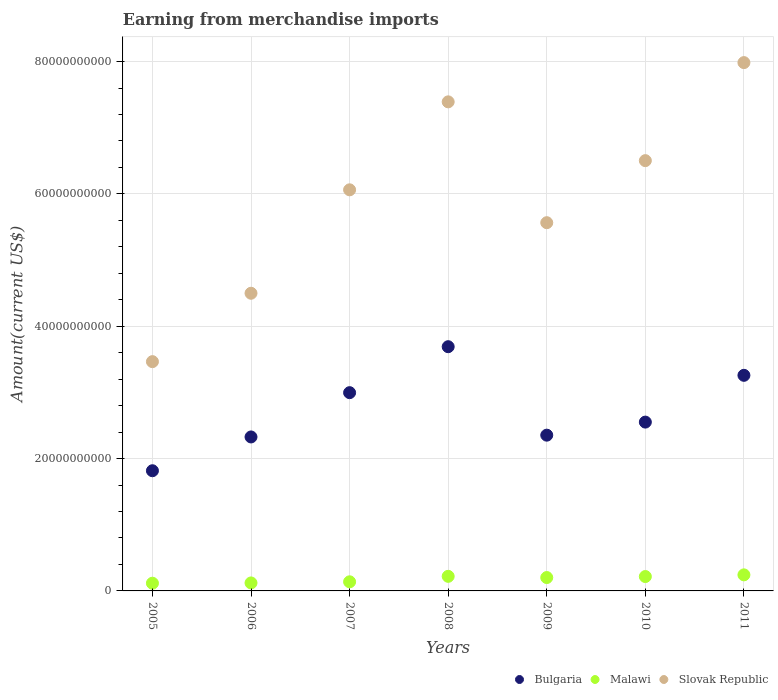Is the number of dotlines equal to the number of legend labels?
Give a very brief answer. Yes. What is the amount earned from merchandise imports in Slovak Republic in 2008?
Offer a very short reply. 7.39e+1. Across all years, what is the maximum amount earned from merchandise imports in Malawi?
Provide a succinct answer. 2.43e+09. Across all years, what is the minimum amount earned from merchandise imports in Malawi?
Offer a very short reply. 1.17e+09. In which year was the amount earned from merchandise imports in Malawi maximum?
Your response must be concise. 2011. What is the total amount earned from merchandise imports in Bulgaria in the graph?
Your answer should be very brief. 1.90e+11. What is the difference between the amount earned from merchandise imports in Bulgaria in 2008 and that in 2011?
Your answer should be very brief. 4.33e+09. What is the difference between the amount earned from merchandise imports in Slovak Republic in 2011 and the amount earned from merchandise imports in Malawi in 2005?
Give a very brief answer. 7.87e+1. What is the average amount earned from merchandise imports in Bulgaria per year?
Offer a very short reply. 2.71e+1. In the year 2010, what is the difference between the amount earned from merchandise imports in Bulgaria and amount earned from merchandise imports in Slovak Republic?
Your answer should be very brief. -3.95e+1. What is the ratio of the amount earned from merchandise imports in Slovak Republic in 2010 to that in 2011?
Keep it short and to the point. 0.81. Is the difference between the amount earned from merchandise imports in Bulgaria in 2006 and 2007 greater than the difference between the amount earned from merchandise imports in Slovak Republic in 2006 and 2007?
Make the answer very short. Yes. What is the difference between the highest and the second highest amount earned from merchandise imports in Bulgaria?
Offer a very short reply. 4.33e+09. What is the difference between the highest and the lowest amount earned from merchandise imports in Slovak Republic?
Offer a very short reply. 4.52e+1. In how many years, is the amount earned from merchandise imports in Slovak Republic greater than the average amount earned from merchandise imports in Slovak Republic taken over all years?
Offer a terse response. 4. How many years are there in the graph?
Make the answer very short. 7. What is the difference between two consecutive major ticks on the Y-axis?
Provide a short and direct response. 2.00e+1. Does the graph contain any zero values?
Ensure brevity in your answer.  No. Where does the legend appear in the graph?
Make the answer very short. Bottom right. How are the legend labels stacked?
Your answer should be very brief. Horizontal. What is the title of the graph?
Make the answer very short. Earning from merchandise imports. What is the label or title of the X-axis?
Provide a succinct answer. Years. What is the label or title of the Y-axis?
Offer a very short reply. Amount(current US$). What is the Amount(current US$) in Bulgaria in 2005?
Offer a terse response. 1.82e+1. What is the Amount(current US$) in Malawi in 2005?
Your answer should be compact. 1.17e+09. What is the Amount(current US$) of Slovak Republic in 2005?
Provide a short and direct response. 3.46e+1. What is the Amount(current US$) in Bulgaria in 2006?
Your response must be concise. 2.33e+1. What is the Amount(current US$) in Malawi in 2006?
Make the answer very short. 1.21e+09. What is the Amount(current US$) in Slovak Republic in 2006?
Your answer should be very brief. 4.50e+1. What is the Amount(current US$) of Bulgaria in 2007?
Your response must be concise. 3.00e+1. What is the Amount(current US$) of Malawi in 2007?
Make the answer very short. 1.38e+09. What is the Amount(current US$) of Slovak Republic in 2007?
Provide a succinct answer. 6.06e+1. What is the Amount(current US$) of Bulgaria in 2008?
Provide a succinct answer. 3.69e+1. What is the Amount(current US$) in Malawi in 2008?
Make the answer very short. 2.20e+09. What is the Amount(current US$) in Slovak Republic in 2008?
Your response must be concise. 7.39e+1. What is the Amount(current US$) of Bulgaria in 2009?
Give a very brief answer. 2.35e+1. What is the Amount(current US$) of Malawi in 2009?
Give a very brief answer. 2.02e+09. What is the Amount(current US$) of Slovak Republic in 2009?
Your answer should be very brief. 5.56e+1. What is the Amount(current US$) of Bulgaria in 2010?
Provide a short and direct response. 2.55e+1. What is the Amount(current US$) of Malawi in 2010?
Make the answer very short. 2.17e+09. What is the Amount(current US$) in Slovak Republic in 2010?
Keep it short and to the point. 6.50e+1. What is the Amount(current US$) of Bulgaria in 2011?
Your answer should be compact. 3.26e+1. What is the Amount(current US$) in Malawi in 2011?
Ensure brevity in your answer.  2.43e+09. What is the Amount(current US$) of Slovak Republic in 2011?
Offer a terse response. 7.98e+1. Across all years, what is the maximum Amount(current US$) in Bulgaria?
Keep it short and to the point. 3.69e+1. Across all years, what is the maximum Amount(current US$) in Malawi?
Offer a terse response. 2.43e+09. Across all years, what is the maximum Amount(current US$) in Slovak Republic?
Provide a short and direct response. 7.98e+1. Across all years, what is the minimum Amount(current US$) of Bulgaria?
Provide a succinct answer. 1.82e+1. Across all years, what is the minimum Amount(current US$) of Malawi?
Make the answer very short. 1.17e+09. Across all years, what is the minimum Amount(current US$) in Slovak Republic?
Give a very brief answer. 3.46e+1. What is the total Amount(current US$) of Bulgaria in the graph?
Offer a very short reply. 1.90e+11. What is the total Amount(current US$) in Malawi in the graph?
Give a very brief answer. 1.26e+1. What is the total Amount(current US$) of Slovak Republic in the graph?
Your answer should be very brief. 4.15e+11. What is the difference between the Amount(current US$) in Bulgaria in 2005 and that in 2006?
Ensure brevity in your answer.  -5.11e+09. What is the difference between the Amount(current US$) in Malawi in 2005 and that in 2006?
Your answer should be very brief. -4.15e+07. What is the difference between the Amount(current US$) in Slovak Republic in 2005 and that in 2006?
Make the answer very short. -1.03e+1. What is the difference between the Amount(current US$) of Bulgaria in 2005 and that in 2007?
Provide a succinct answer. -1.18e+1. What is the difference between the Amount(current US$) of Malawi in 2005 and that in 2007?
Offer a very short reply. -2.13e+08. What is the difference between the Amount(current US$) of Slovak Republic in 2005 and that in 2007?
Make the answer very short. -2.60e+1. What is the difference between the Amount(current US$) in Bulgaria in 2005 and that in 2008?
Make the answer very short. -1.87e+1. What is the difference between the Amount(current US$) of Malawi in 2005 and that in 2008?
Give a very brief answer. -1.04e+09. What is the difference between the Amount(current US$) of Slovak Republic in 2005 and that in 2008?
Give a very brief answer. -3.93e+1. What is the difference between the Amount(current US$) of Bulgaria in 2005 and that in 2009?
Offer a very short reply. -5.38e+09. What is the difference between the Amount(current US$) in Malawi in 2005 and that in 2009?
Provide a succinct answer. -8.56e+08. What is the difference between the Amount(current US$) of Slovak Republic in 2005 and that in 2009?
Your response must be concise. -2.10e+1. What is the difference between the Amount(current US$) in Bulgaria in 2005 and that in 2010?
Your answer should be compact. -7.35e+09. What is the difference between the Amount(current US$) of Malawi in 2005 and that in 2010?
Ensure brevity in your answer.  -1.01e+09. What is the difference between the Amount(current US$) in Slovak Republic in 2005 and that in 2010?
Give a very brief answer. -3.04e+1. What is the difference between the Amount(current US$) of Bulgaria in 2005 and that in 2011?
Offer a very short reply. -1.44e+1. What is the difference between the Amount(current US$) in Malawi in 2005 and that in 2011?
Keep it short and to the point. -1.26e+09. What is the difference between the Amount(current US$) of Slovak Republic in 2005 and that in 2011?
Your answer should be very brief. -4.52e+1. What is the difference between the Amount(current US$) of Bulgaria in 2006 and that in 2007?
Make the answer very short. -6.69e+09. What is the difference between the Amount(current US$) of Malawi in 2006 and that in 2007?
Your answer should be very brief. -1.71e+08. What is the difference between the Amount(current US$) in Slovak Republic in 2006 and that in 2007?
Keep it short and to the point. -1.56e+1. What is the difference between the Amount(current US$) in Bulgaria in 2006 and that in 2008?
Ensure brevity in your answer.  -1.36e+1. What is the difference between the Amount(current US$) of Malawi in 2006 and that in 2008?
Keep it short and to the point. -9.97e+08. What is the difference between the Amount(current US$) in Slovak Republic in 2006 and that in 2008?
Your answer should be very brief. -2.89e+1. What is the difference between the Amount(current US$) of Bulgaria in 2006 and that in 2009?
Make the answer very short. -2.69e+08. What is the difference between the Amount(current US$) of Malawi in 2006 and that in 2009?
Your answer should be very brief. -8.15e+08. What is the difference between the Amount(current US$) of Slovak Republic in 2006 and that in 2009?
Your answer should be very brief. -1.07e+1. What is the difference between the Amount(current US$) in Bulgaria in 2006 and that in 2010?
Your response must be concise. -2.24e+09. What is the difference between the Amount(current US$) in Malawi in 2006 and that in 2010?
Offer a terse response. -9.66e+08. What is the difference between the Amount(current US$) of Slovak Republic in 2006 and that in 2010?
Keep it short and to the point. -2.00e+1. What is the difference between the Amount(current US$) in Bulgaria in 2006 and that in 2011?
Your answer should be compact. -9.31e+09. What is the difference between the Amount(current US$) in Malawi in 2006 and that in 2011?
Keep it short and to the point. -1.22e+09. What is the difference between the Amount(current US$) in Slovak Republic in 2006 and that in 2011?
Your answer should be very brief. -3.49e+1. What is the difference between the Amount(current US$) of Bulgaria in 2007 and that in 2008?
Keep it short and to the point. -6.95e+09. What is the difference between the Amount(current US$) of Malawi in 2007 and that in 2008?
Provide a short and direct response. -8.26e+08. What is the difference between the Amount(current US$) in Slovak Republic in 2007 and that in 2008?
Ensure brevity in your answer.  -1.33e+1. What is the difference between the Amount(current US$) in Bulgaria in 2007 and that in 2009?
Offer a terse response. 6.42e+09. What is the difference between the Amount(current US$) in Malawi in 2007 and that in 2009?
Provide a succinct answer. -6.44e+08. What is the difference between the Amount(current US$) of Slovak Republic in 2007 and that in 2009?
Your response must be concise. 4.97e+09. What is the difference between the Amount(current US$) of Bulgaria in 2007 and that in 2010?
Give a very brief answer. 4.45e+09. What is the difference between the Amount(current US$) in Malawi in 2007 and that in 2010?
Provide a succinct answer. -7.95e+08. What is the difference between the Amount(current US$) of Slovak Republic in 2007 and that in 2010?
Your answer should be very brief. -4.41e+09. What is the difference between the Amount(current US$) in Bulgaria in 2007 and that in 2011?
Keep it short and to the point. -2.62e+09. What is the difference between the Amount(current US$) of Malawi in 2007 and that in 2011?
Your answer should be compact. -1.05e+09. What is the difference between the Amount(current US$) of Slovak Republic in 2007 and that in 2011?
Your response must be concise. -1.92e+1. What is the difference between the Amount(current US$) in Bulgaria in 2008 and that in 2009?
Offer a terse response. 1.34e+1. What is the difference between the Amount(current US$) of Malawi in 2008 and that in 2009?
Make the answer very short. 1.82e+08. What is the difference between the Amount(current US$) of Slovak Republic in 2008 and that in 2009?
Offer a very short reply. 1.83e+1. What is the difference between the Amount(current US$) of Bulgaria in 2008 and that in 2010?
Provide a short and direct response. 1.14e+1. What is the difference between the Amount(current US$) in Malawi in 2008 and that in 2010?
Give a very brief answer. 3.06e+07. What is the difference between the Amount(current US$) in Slovak Republic in 2008 and that in 2010?
Offer a terse response. 8.89e+09. What is the difference between the Amount(current US$) in Bulgaria in 2008 and that in 2011?
Offer a terse response. 4.33e+09. What is the difference between the Amount(current US$) in Malawi in 2008 and that in 2011?
Your answer should be compact. -2.24e+08. What is the difference between the Amount(current US$) of Slovak Republic in 2008 and that in 2011?
Give a very brief answer. -5.93e+09. What is the difference between the Amount(current US$) of Bulgaria in 2009 and that in 2010?
Provide a succinct answer. -1.97e+09. What is the difference between the Amount(current US$) of Malawi in 2009 and that in 2010?
Your answer should be very brief. -1.51e+08. What is the difference between the Amount(current US$) in Slovak Republic in 2009 and that in 2010?
Keep it short and to the point. -9.38e+09. What is the difference between the Amount(current US$) of Bulgaria in 2009 and that in 2011?
Provide a short and direct response. -9.04e+09. What is the difference between the Amount(current US$) in Malawi in 2009 and that in 2011?
Give a very brief answer. -4.06e+08. What is the difference between the Amount(current US$) of Slovak Republic in 2009 and that in 2011?
Your response must be concise. -2.42e+1. What is the difference between the Amount(current US$) of Bulgaria in 2010 and that in 2011?
Keep it short and to the point. -7.07e+09. What is the difference between the Amount(current US$) of Malawi in 2010 and that in 2011?
Your answer should be very brief. -2.55e+08. What is the difference between the Amount(current US$) in Slovak Republic in 2010 and that in 2011?
Your response must be concise. -1.48e+1. What is the difference between the Amount(current US$) in Bulgaria in 2005 and the Amount(current US$) in Malawi in 2006?
Your response must be concise. 1.70e+1. What is the difference between the Amount(current US$) of Bulgaria in 2005 and the Amount(current US$) of Slovak Republic in 2006?
Ensure brevity in your answer.  -2.68e+1. What is the difference between the Amount(current US$) in Malawi in 2005 and the Amount(current US$) in Slovak Republic in 2006?
Ensure brevity in your answer.  -4.38e+1. What is the difference between the Amount(current US$) in Bulgaria in 2005 and the Amount(current US$) in Malawi in 2007?
Make the answer very short. 1.68e+1. What is the difference between the Amount(current US$) in Bulgaria in 2005 and the Amount(current US$) in Slovak Republic in 2007?
Give a very brief answer. -4.25e+1. What is the difference between the Amount(current US$) of Malawi in 2005 and the Amount(current US$) of Slovak Republic in 2007?
Give a very brief answer. -5.95e+1. What is the difference between the Amount(current US$) in Bulgaria in 2005 and the Amount(current US$) in Malawi in 2008?
Ensure brevity in your answer.  1.60e+1. What is the difference between the Amount(current US$) in Bulgaria in 2005 and the Amount(current US$) in Slovak Republic in 2008?
Provide a succinct answer. -5.57e+1. What is the difference between the Amount(current US$) of Malawi in 2005 and the Amount(current US$) of Slovak Republic in 2008?
Make the answer very short. -7.27e+1. What is the difference between the Amount(current US$) in Bulgaria in 2005 and the Amount(current US$) in Malawi in 2009?
Keep it short and to the point. 1.61e+1. What is the difference between the Amount(current US$) of Bulgaria in 2005 and the Amount(current US$) of Slovak Republic in 2009?
Offer a terse response. -3.75e+1. What is the difference between the Amount(current US$) of Malawi in 2005 and the Amount(current US$) of Slovak Republic in 2009?
Offer a very short reply. -5.45e+1. What is the difference between the Amount(current US$) of Bulgaria in 2005 and the Amount(current US$) of Malawi in 2010?
Make the answer very short. 1.60e+1. What is the difference between the Amount(current US$) in Bulgaria in 2005 and the Amount(current US$) in Slovak Republic in 2010?
Keep it short and to the point. -4.69e+1. What is the difference between the Amount(current US$) in Malawi in 2005 and the Amount(current US$) in Slovak Republic in 2010?
Offer a very short reply. -6.39e+1. What is the difference between the Amount(current US$) in Bulgaria in 2005 and the Amount(current US$) in Malawi in 2011?
Your response must be concise. 1.57e+1. What is the difference between the Amount(current US$) of Bulgaria in 2005 and the Amount(current US$) of Slovak Republic in 2011?
Your answer should be very brief. -6.17e+1. What is the difference between the Amount(current US$) of Malawi in 2005 and the Amount(current US$) of Slovak Republic in 2011?
Your response must be concise. -7.87e+1. What is the difference between the Amount(current US$) of Bulgaria in 2006 and the Amount(current US$) of Malawi in 2007?
Make the answer very short. 2.19e+1. What is the difference between the Amount(current US$) in Bulgaria in 2006 and the Amount(current US$) in Slovak Republic in 2007?
Your answer should be compact. -3.73e+1. What is the difference between the Amount(current US$) in Malawi in 2006 and the Amount(current US$) in Slovak Republic in 2007?
Provide a succinct answer. -5.94e+1. What is the difference between the Amount(current US$) in Bulgaria in 2006 and the Amount(current US$) in Malawi in 2008?
Offer a very short reply. 2.11e+1. What is the difference between the Amount(current US$) in Bulgaria in 2006 and the Amount(current US$) in Slovak Republic in 2008?
Keep it short and to the point. -5.06e+1. What is the difference between the Amount(current US$) in Malawi in 2006 and the Amount(current US$) in Slovak Republic in 2008?
Your answer should be very brief. -7.27e+1. What is the difference between the Amount(current US$) of Bulgaria in 2006 and the Amount(current US$) of Malawi in 2009?
Make the answer very short. 2.12e+1. What is the difference between the Amount(current US$) of Bulgaria in 2006 and the Amount(current US$) of Slovak Republic in 2009?
Provide a succinct answer. -3.24e+1. What is the difference between the Amount(current US$) of Malawi in 2006 and the Amount(current US$) of Slovak Republic in 2009?
Offer a terse response. -5.44e+1. What is the difference between the Amount(current US$) of Bulgaria in 2006 and the Amount(current US$) of Malawi in 2010?
Offer a very short reply. 2.11e+1. What is the difference between the Amount(current US$) of Bulgaria in 2006 and the Amount(current US$) of Slovak Republic in 2010?
Your answer should be very brief. -4.18e+1. What is the difference between the Amount(current US$) in Malawi in 2006 and the Amount(current US$) in Slovak Republic in 2010?
Make the answer very short. -6.38e+1. What is the difference between the Amount(current US$) in Bulgaria in 2006 and the Amount(current US$) in Malawi in 2011?
Offer a very short reply. 2.08e+1. What is the difference between the Amount(current US$) of Bulgaria in 2006 and the Amount(current US$) of Slovak Republic in 2011?
Give a very brief answer. -5.66e+1. What is the difference between the Amount(current US$) of Malawi in 2006 and the Amount(current US$) of Slovak Republic in 2011?
Make the answer very short. -7.86e+1. What is the difference between the Amount(current US$) in Bulgaria in 2007 and the Amount(current US$) in Malawi in 2008?
Offer a very short reply. 2.78e+1. What is the difference between the Amount(current US$) of Bulgaria in 2007 and the Amount(current US$) of Slovak Republic in 2008?
Your answer should be very brief. -4.40e+1. What is the difference between the Amount(current US$) in Malawi in 2007 and the Amount(current US$) in Slovak Republic in 2008?
Provide a short and direct response. -7.25e+1. What is the difference between the Amount(current US$) of Bulgaria in 2007 and the Amount(current US$) of Malawi in 2009?
Your response must be concise. 2.79e+1. What is the difference between the Amount(current US$) of Bulgaria in 2007 and the Amount(current US$) of Slovak Republic in 2009?
Offer a terse response. -2.57e+1. What is the difference between the Amount(current US$) of Malawi in 2007 and the Amount(current US$) of Slovak Republic in 2009?
Provide a short and direct response. -5.43e+1. What is the difference between the Amount(current US$) of Bulgaria in 2007 and the Amount(current US$) of Malawi in 2010?
Make the answer very short. 2.78e+1. What is the difference between the Amount(current US$) in Bulgaria in 2007 and the Amount(current US$) in Slovak Republic in 2010?
Provide a succinct answer. -3.51e+1. What is the difference between the Amount(current US$) in Malawi in 2007 and the Amount(current US$) in Slovak Republic in 2010?
Your answer should be compact. -6.36e+1. What is the difference between the Amount(current US$) of Bulgaria in 2007 and the Amount(current US$) of Malawi in 2011?
Your response must be concise. 2.75e+1. What is the difference between the Amount(current US$) in Bulgaria in 2007 and the Amount(current US$) in Slovak Republic in 2011?
Your response must be concise. -4.99e+1. What is the difference between the Amount(current US$) in Malawi in 2007 and the Amount(current US$) in Slovak Republic in 2011?
Provide a succinct answer. -7.85e+1. What is the difference between the Amount(current US$) in Bulgaria in 2008 and the Amount(current US$) in Malawi in 2009?
Provide a short and direct response. 3.49e+1. What is the difference between the Amount(current US$) in Bulgaria in 2008 and the Amount(current US$) in Slovak Republic in 2009?
Provide a short and direct response. -1.87e+1. What is the difference between the Amount(current US$) of Malawi in 2008 and the Amount(current US$) of Slovak Republic in 2009?
Provide a succinct answer. -5.34e+1. What is the difference between the Amount(current US$) of Bulgaria in 2008 and the Amount(current US$) of Malawi in 2010?
Offer a very short reply. 3.47e+1. What is the difference between the Amount(current US$) in Bulgaria in 2008 and the Amount(current US$) in Slovak Republic in 2010?
Make the answer very short. -2.81e+1. What is the difference between the Amount(current US$) in Malawi in 2008 and the Amount(current US$) in Slovak Republic in 2010?
Offer a very short reply. -6.28e+1. What is the difference between the Amount(current US$) in Bulgaria in 2008 and the Amount(current US$) in Malawi in 2011?
Offer a terse response. 3.45e+1. What is the difference between the Amount(current US$) in Bulgaria in 2008 and the Amount(current US$) in Slovak Republic in 2011?
Offer a very short reply. -4.29e+1. What is the difference between the Amount(current US$) in Malawi in 2008 and the Amount(current US$) in Slovak Republic in 2011?
Provide a succinct answer. -7.76e+1. What is the difference between the Amount(current US$) in Bulgaria in 2009 and the Amount(current US$) in Malawi in 2010?
Offer a very short reply. 2.14e+1. What is the difference between the Amount(current US$) in Bulgaria in 2009 and the Amount(current US$) in Slovak Republic in 2010?
Give a very brief answer. -4.15e+1. What is the difference between the Amount(current US$) of Malawi in 2009 and the Amount(current US$) of Slovak Republic in 2010?
Your response must be concise. -6.30e+1. What is the difference between the Amount(current US$) in Bulgaria in 2009 and the Amount(current US$) in Malawi in 2011?
Provide a short and direct response. 2.11e+1. What is the difference between the Amount(current US$) in Bulgaria in 2009 and the Amount(current US$) in Slovak Republic in 2011?
Your response must be concise. -5.63e+1. What is the difference between the Amount(current US$) in Malawi in 2009 and the Amount(current US$) in Slovak Republic in 2011?
Keep it short and to the point. -7.78e+1. What is the difference between the Amount(current US$) of Bulgaria in 2010 and the Amount(current US$) of Malawi in 2011?
Keep it short and to the point. 2.31e+1. What is the difference between the Amount(current US$) in Bulgaria in 2010 and the Amount(current US$) in Slovak Republic in 2011?
Offer a terse response. -5.43e+1. What is the difference between the Amount(current US$) in Malawi in 2010 and the Amount(current US$) in Slovak Republic in 2011?
Give a very brief answer. -7.77e+1. What is the average Amount(current US$) of Bulgaria per year?
Give a very brief answer. 2.71e+1. What is the average Amount(current US$) of Malawi per year?
Provide a succinct answer. 1.80e+09. What is the average Amount(current US$) in Slovak Republic per year?
Make the answer very short. 5.92e+1. In the year 2005, what is the difference between the Amount(current US$) of Bulgaria and Amount(current US$) of Malawi?
Offer a terse response. 1.70e+1. In the year 2005, what is the difference between the Amount(current US$) in Bulgaria and Amount(current US$) in Slovak Republic?
Provide a succinct answer. -1.65e+1. In the year 2005, what is the difference between the Amount(current US$) in Malawi and Amount(current US$) in Slovak Republic?
Your response must be concise. -3.35e+1. In the year 2006, what is the difference between the Amount(current US$) in Bulgaria and Amount(current US$) in Malawi?
Your response must be concise. 2.21e+1. In the year 2006, what is the difference between the Amount(current US$) of Bulgaria and Amount(current US$) of Slovak Republic?
Your response must be concise. -2.17e+1. In the year 2006, what is the difference between the Amount(current US$) in Malawi and Amount(current US$) in Slovak Republic?
Offer a terse response. -4.38e+1. In the year 2007, what is the difference between the Amount(current US$) in Bulgaria and Amount(current US$) in Malawi?
Offer a very short reply. 2.86e+1. In the year 2007, what is the difference between the Amount(current US$) in Bulgaria and Amount(current US$) in Slovak Republic?
Offer a terse response. -3.07e+1. In the year 2007, what is the difference between the Amount(current US$) in Malawi and Amount(current US$) in Slovak Republic?
Offer a very short reply. -5.92e+1. In the year 2008, what is the difference between the Amount(current US$) of Bulgaria and Amount(current US$) of Malawi?
Give a very brief answer. 3.47e+1. In the year 2008, what is the difference between the Amount(current US$) of Bulgaria and Amount(current US$) of Slovak Republic?
Your answer should be compact. -3.70e+1. In the year 2008, what is the difference between the Amount(current US$) of Malawi and Amount(current US$) of Slovak Republic?
Offer a very short reply. -7.17e+1. In the year 2009, what is the difference between the Amount(current US$) of Bulgaria and Amount(current US$) of Malawi?
Your response must be concise. 2.15e+1. In the year 2009, what is the difference between the Amount(current US$) in Bulgaria and Amount(current US$) in Slovak Republic?
Offer a terse response. -3.21e+1. In the year 2009, what is the difference between the Amount(current US$) of Malawi and Amount(current US$) of Slovak Republic?
Your answer should be very brief. -5.36e+1. In the year 2010, what is the difference between the Amount(current US$) of Bulgaria and Amount(current US$) of Malawi?
Your answer should be very brief. 2.33e+1. In the year 2010, what is the difference between the Amount(current US$) of Bulgaria and Amount(current US$) of Slovak Republic?
Offer a very short reply. -3.95e+1. In the year 2010, what is the difference between the Amount(current US$) of Malawi and Amount(current US$) of Slovak Republic?
Your response must be concise. -6.29e+1. In the year 2011, what is the difference between the Amount(current US$) in Bulgaria and Amount(current US$) in Malawi?
Your response must be concise. 3.02e+1. In the year 2011, what is the difference between the Amount(current US$) of Bulgaria and Amount(current US$) of Slovak Republic?
Your answer should be compact. -4.73e+1. In the year 2011, what is the difference between the Amount(current US$) in Malawi and Amount(current US$) in Slovak Republic?
Provide a short and direct response. -7.74e+1. What is the ratio of the Amount(current US$) of Bulgaria in 2005 to that in 2006?
Keep it short and to the point. 0.78. What is the ratio of the Amount(current US$) of Malawi in 2005 to that in 2006?
Your answer should be very brief. 0.97. What is the ratio of the Amount(current US$) in Slovak Republic in 2005 to that in 2006?
Keep it short and to the point. 0.77. What is the ratio of the Amount(current US$) of Bulgaria in 2005 to that in 2007?
Make the answer very short. 0.61. What is the ratio of the Amount(current US$) in Malawi in 2005 to that in 2007?
Your answer should be very brief. 0.85. What is the ratio of the Amount(current US$) of Slovak Republic in 2005 to that in 2007?
Your answer should be compact. 0.57. What is the ratio of the Amount(current US$) of Bulgaria in 2005 to that in 2008?
Offer a very short reply. 0.49. What is the ratio of the Amount(current US$) in Malawi in 2005 to that in 2008?
Offer a terse response. 0.53. What is the ratio of the Amount(current US$) in Slovak Republic in 2005 to that in 2008?
Your answer should be very brief. 0.47. What is the ratio of the Amount(current US$) of Bulgaria in 2005 to that in 2009?
Keep it short and to the point. 0.77. What is the ratio of the Amount(current US$) in Malawi in 2005 to that in 2009?
Offer a very short reply. 0.58. What is the ratio of the Amount(current US$) in Slovak Republic in 2005 to that in 2009?
Offer a terse response. 0.62. What is the ratio of the Amount(current US$) in Bulgaria in 2005 to that in 2010?
Provide a succinct answer. 0.71. What is the ratio of the Amount(current US$) of Malawi in 2005 to that in 2010?
Your answer should be very brief. 0.54. What is the ratio of the Amount(current US$) in Slovak Republic in 2005 to that in 2010?
Offer a terse response. 0.53. What is the ratio of the Amount(current US$) in Bulgaria in 2005 to that in 2011?
Offer a very short reply. 0.56. What is the ratio of the Amount(current US$) of Malawi in 2005 to that in 2011?
Keep it short and to the point. 0.48. What is the ratio of the Amount(current US$) of Slovak Republic in 2005 to that in 2011?
Offer a very short reply. 0.43. What is the ratio of the Amount(current US$) of Bulgaria in 2006 to that in 2007?
Your answer should be compact. 0.78. What is the ratio of the Amount(current US$) of Malawi in 2006 to that in 2007?
Offer a terse response. 0.88. What is the ratio of the Amount(current US$) in Slovak Republic in 2006 to that in 2007?
Your response must be concise. 0.74. What is the ratio of the Amount(current US$) of Bulgaria in 2006 to that in 2008?
Provide a succinct answer. 0.63. What is the ratio of the Amount(current US$) of Malawi in 2006 to that in 2008?
Your response must be concise. 0.55. What is the ratio of the Amount(current US$) of Slovak Republic in 2006 to that in 2008?
Make the answer very short. 0.61. What is the ratio of the Amount(current US$) in Malawi in 2006 to that in 2009?
Your answer should be very brief. 0.6. What is the ratio of the Amount(current US$) in Slovak Republic in 2006 to that in 2009?
Your response must be concise. 0.81. What is the ratio of the Amount(current US$) of Bulgaria in 2006 to that in 2010?
Give a very brief answer. 0.91. What is the ratio of the Amount(current US$) in Malawi in 2006 to that in 2010?
Your answer should be very brief. 0.56. What is the ratio of the Amount(current US$) in Slovak Republic in 2006 to that in 2010?
Give a very brief answer. 0.69. What is the ratio of the Amount(current US$) in Bulgaria in 2006 to that in 2011?
Offer a terse response. 0.71. What is the ratio of the Amount(current US$) of Malawi in 2006 to that in 2011?
Give a very brief answer. 0.5. What is the ratio of the Amount(current US$) in Slovak Republic in 2006 to that in 2011?
Your response must be concise. 0.56. What is the ratio of the Amount(current US$) in Bulgaria in 2007 to that in 2008?
Make the answer very short. 0.81. What is the ratio of the Amount(current US$) in Malawi in 2007 to that in 2008?
Provide a short and direct response. 0.63. What is the ratio of the Amount(current US$) in Slovak Republic in 2007 to that in 2008?
Provide a succinct answer. 0.82. What is the ratio of the Amount(current US$) of Bulgaria in 2007 to that in 2009?
Your answer should be compact. 1.27. What is the ratio of the Amount(current US$) in Malawi in 2007 to that in 2009?
Your response must be concise. 0.68. What is the ratio of the Amount(current US$) in Slovak Republic in 2007 to that in 2009?
Offer a very short reply. 1.09. What is the ratio of the Amount(current US$) of Bulgaria in 2007 to that in 2010?
Your answer should be compact. 1.17. What is the ratio of the Amount(current US$) of Malawi in 2007 to that in 2010?
Your answer should be compact. 0.63. What is the ratio of the Amount(current US$) of Slovak Republic in 2007 to that in 2010?
Provide a succinct answer. 0.93. What is the ratio of the Amount(current US$) in Bulgaria in 2007 to that in 2011?
Offer a very short reply. 0.92. What is the ratio of the Amount(current US$) of Malawi in 2007 to that in 2011?
Ensure brevity in your answer.  0.57. What is the ratio of the Amount(current US$) of Slovak Republic in 2007 to that in 2011?
Ensure brevity in your answer.  0.76. What is the ratio of the Amount(current US$) in Bulgaria in 2008 to that in 2009?
Provide a short and direct response. 1.57. What is the ratio of the Amount(current US$) of Malawi in 2008 to that in 2009?
Your answer should be compact. 1.09. What is the ratio of the Amount(current US$) in Slovak Republic in 2008 to that in 2009?
Your answer should be compact. 1.33. What is the ratio of the Amount(current US$) of Bulgaria in 2008 to that in 2010?
Your answer should be compact. 1.45. What is the ratio of the Amount(current US$) in Malawi in 2008 to that in 2010?
Offer a very short reply. 1.01. What is the ratio of the Amount(current US$) in Slovak Republic in 2008 to that in 2010?
Keep it short and to the point. 1.14. What is the ratio of the Amount(current US$) in Bulgaria in 2008 to that in 2011?
Keep it short and to the point. 1.13. What is the ratio of the Amount(current US$) in Malawi in 2008 to that in 2011?
Ensure brevity in your answer.  0.91. What is the ratio of the Amount(current US$) of Slovak Republic in 2008 to that in 2011?
Make the answer very short. 0.93. What is the ratio of the Amount(current US$) in Bulgaria in 2009 to that in 2010?
Ensure brevity in your answer.  0.92. What is the ratio of the Amount(current US$) of Malawi in 2009 to that in 2010?
Your response must be concise. 0.93. What is the ratio of the Amount(current US$) of Slovak Republic in 2009 to that in 2010?
Your answer should be compact. 0.86. What is the ratio of the Amount(current US$) in Bulgaria in 2009 to that in 2011?
Provide a succinct answer. 0.72. What is the ratio of the Amount(current US$) in Malawi in 2009 to that in 2011?
Offer a terse response. 0.83. What is the ratio of the Amount(current US$) of Slovak Republic in 2009 to that in 2011?
Provide a short and direct response. 0.7. What is the ratio of the Amount(current US$) of Bulgaria in 2010 to that in 2011?
Your answer should be very brief. 0.78. What is the ratio of the Amount(current US$) in Malawi in 2010 to that in 2011?
Offer a very short reply. 0.9. What is the ratio of the Amount(current US$) in Slovak Republic in 2010 to that in 2011?
Provide a short and direct response. 0.81. What is the difference between the highest and the second highest Amount(current US$) of Bulgaria?
Provide a short and direct response. 4.33e+09. What is the difference between the highest and the second highest Amount(current US$) of Malawi?
Offer a terse response. 2.24e+08. What is the difference between the highest and the second highest Amount(current US$) in Slovak Republic?
Provide a short and direct response. 5.93e+09. What is the difference between the highest and the lowest Amount(current US$) of Bulgaria?
Your response must be concise. 1.87e+1. What is the difference between the highest and the lowest Amount(current US$) in Malawi?
Give a very brief answer. 1.26e+09. What is the difference between the highest and the lowest Amount(current US$) in Slovak Republic?
Your response must be concise. 4.52e+1. 